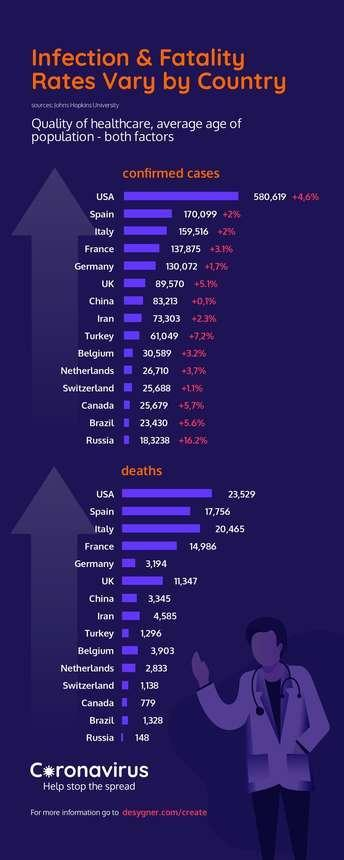What is the number of COVID-19 deaths reported in China?
Answer the question with a short phrase. 3,345 Which country reported the second highest number of confirmed COVID-19 cases? Spain Which country has reported the least number of confirmed COVID-19 cases? Russia What is the number of confirmed COVID-19 cases in Canada? 25,679 What is the number of COVID-19 deaths reported in Italy? 20,465 What is the number of confirmed COVID-19 cases in the UK? 89,570 Which country has reported the least number of COVID-19 deaths? Russia Which country reported the highest number of confirmed COVID-19 cases? USA 